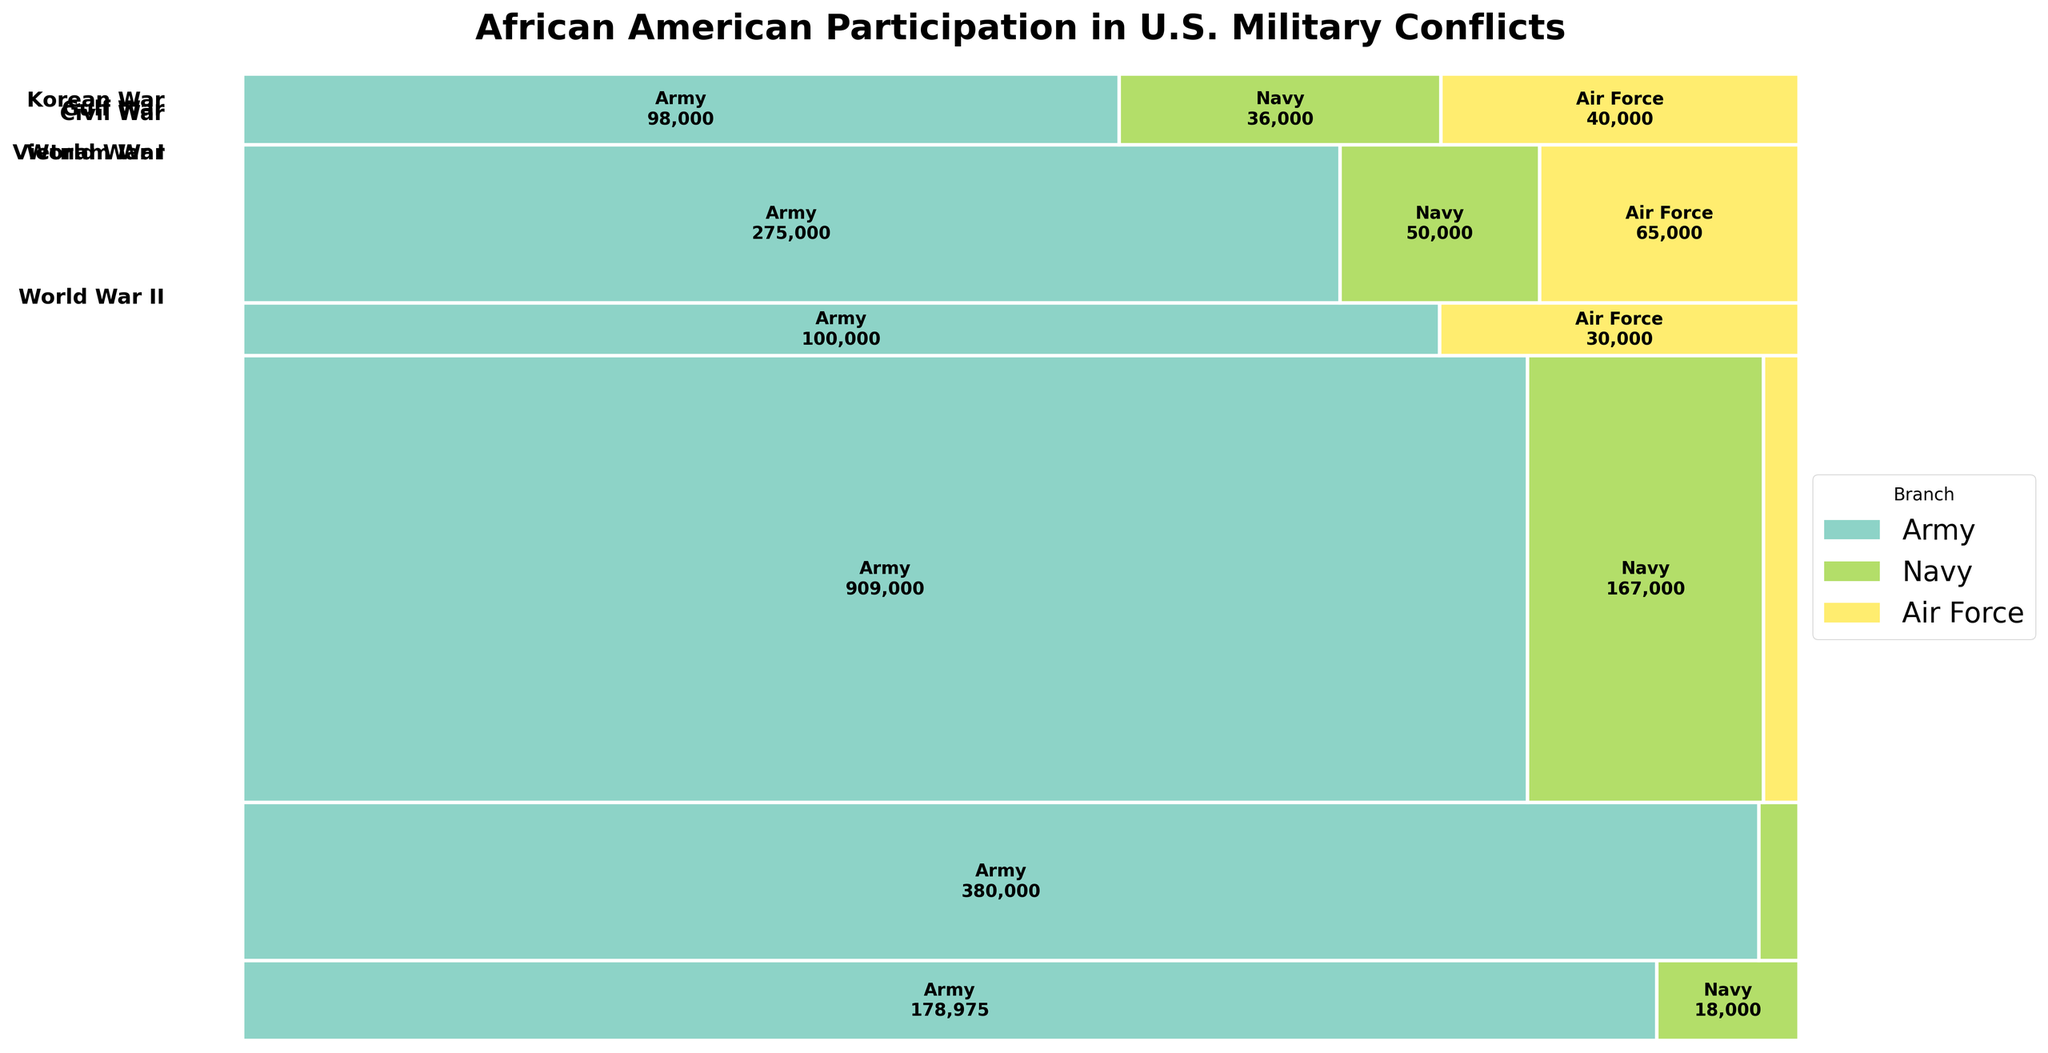What is the title of the figure? The title is located at the top of the figure and typically summarizes the main topic of the plot. Look at the top-center to find it.
Answer: African American Participation in U.S. Military Conflicts Which war had the highest participation in the Army branch? Examine the mosaic plot and identify which war bar segment is the largest in the Army section, indicated by the corresponding label and color.
Answer: World War II How many branches of service are represented in the Korean War? Look at the Korean War segment of the mosaic plot, and count the distinct branch colors represented.
Answer: Two (Army, Air Force) What is the total African American participation in the Vietnam War? Locate the Vietnam War segment and sum the values shown for all branches within this war.
Answer: 390,000 How does the participation in the Navy branch during the Civil War compare to that in World War II? Compare the size of the Navy segments in the Civil War and World War II sections. Note the values and determine which is larger.
Answer: The Navy participation in World War II is higher What percentage of the total African American participation in the Civil War was in the Navy? Divide the Navy participation by the total participation in the Civil War and multiply by 100. (18000 / (178975 + 18000)) * 100
Answer: 9.14% Which branch of service shows participation across all wars listed? Identify the branch that appears in all war segments by its consistent color and presence.
Answer: Army Is there a war where the Air Force has a higher participation than the Navy? Compare the values in the Air Force and Navy segments across all wars and identify any instances where the Air Force number is greater.
Answer: Vietnam War What is the relative size of the Army participation in the Gulf War compared to the Korean War? Compare the values of the Army segments in the Gulf War and Korean War sections. Determine the ratio or percentage difference.
Answer: The Army participation is slightly lower in the Gulf War compared to the Korean War 